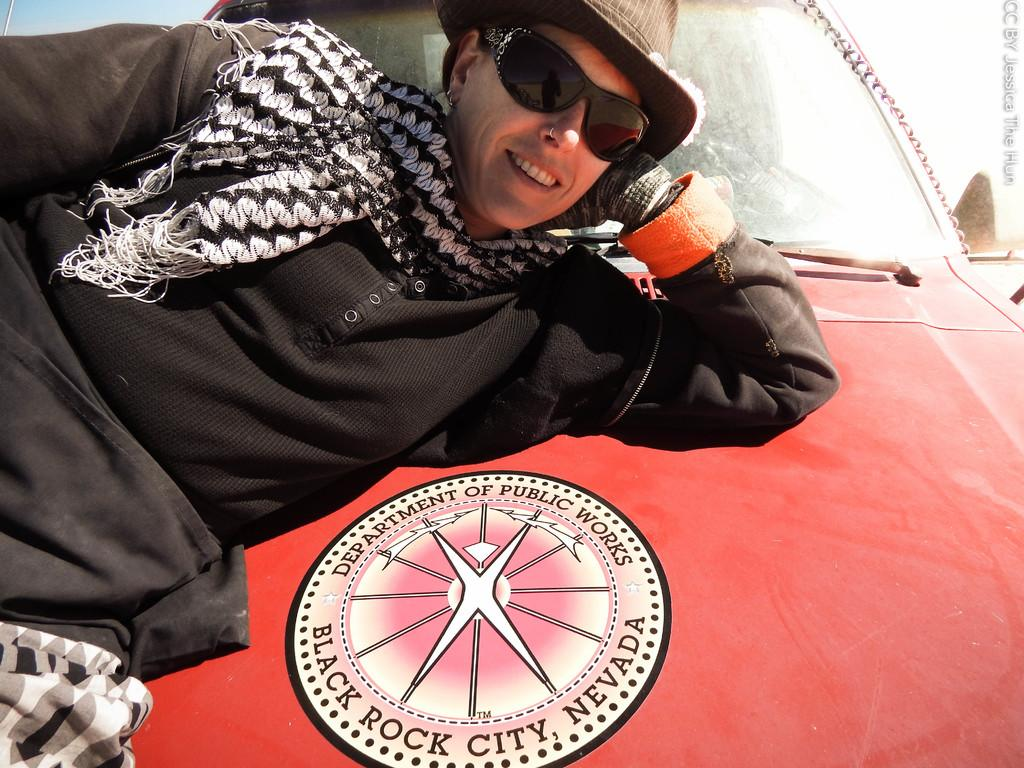What is the person in the image doing? The person is lying on a vehicle in the image. What else can be seen in the image besides the person and the vehicle? There is some text in the top right of the image, and the sky is visible in the top left of the image. How many hills are visible in the image? There are no hills visible in the image. What fact can be determined about the person's age from the image? The image does not provide any information about the person's age, so no fact can be determined. 